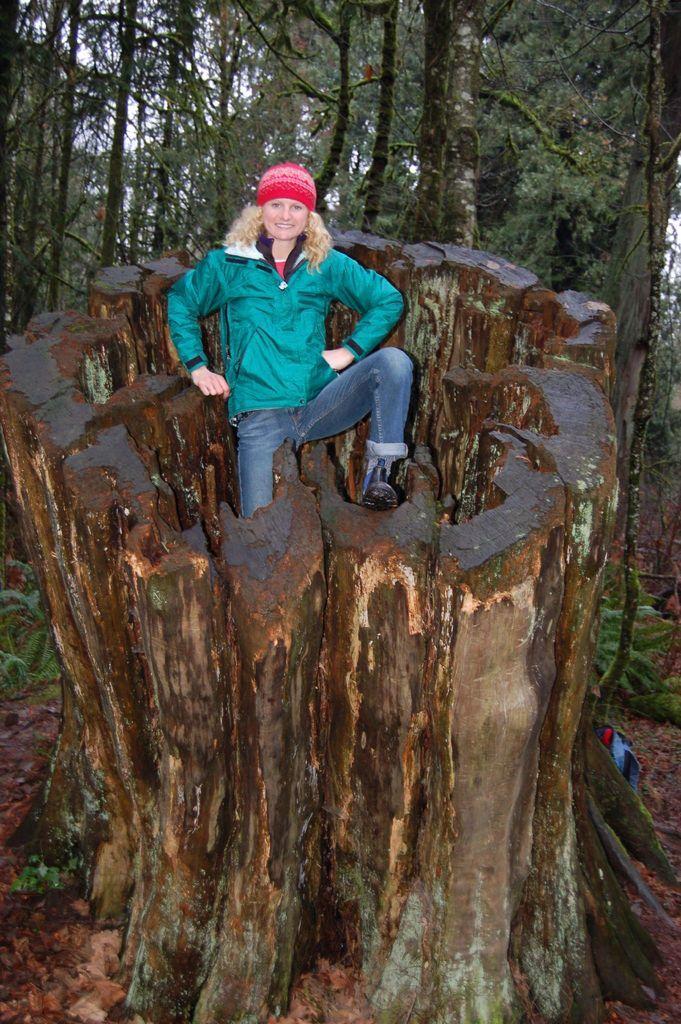Could you give a brief overview of what you see in this image? In this image, I can see the woman standing and smiling. I think she is standing on the tree trunk. These are the trees with branches and leaves. 